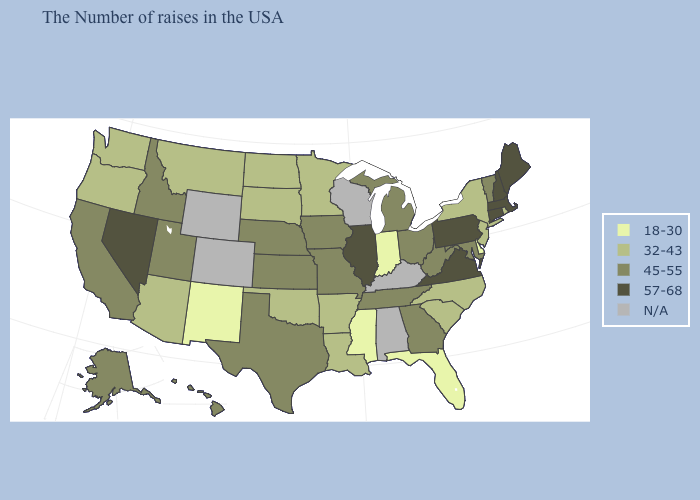What is the lowest value in states that border Iowa?
Concise answer only. 32-43. Name the states that have a value in the range 32-43?
Keep it brief. Rhode Island, New York, New Jersey, North Carolina, South Carolina, Louisiana, Arkansas, Minnesota, Oklahoma, South Dakota, North Dakota, Montana, Arizona, Washington, Oregon. What is the value of Georgia?
Quick response, please. 45-55. What is the lowest value in the USA?
Be succinct. 18-30. Name the states that have a value in the range N/A?
Give a very brief answer. Kentucky, Alabama, Wisconsin, Wyoming, Colorado. Among the states that border Arizona , which have the highest value?
Be succinct. Nevada. What is the value of Idaho?
Be succinct. 45-55. Is the legend a continuous bar?
Quick response, please. No. Name the states that have a value in the range 32-43?
Short answer required. Rhode Island, New York, New Jersey, North Carolina, South Carolina, Louisiana, Arkansas, Minnesota, Oklahoma, South Dakota, North Dakota, Montana, Arizona, Washington, Oregon. Among the states that border Indiana , which have the lowest value?
Quick response, please. Ohio, Michigan. How many symbols are there in the legend?
Be succinct. 5. What is the value of New Mexico?
Answer briefly. 18-30. Which states have the lowest value in the USA?
Keep it brief. Delaware, Florida, Indiana, Mississippi, New Mexico. Does the map have missing data?
Be succinct. Yes. 